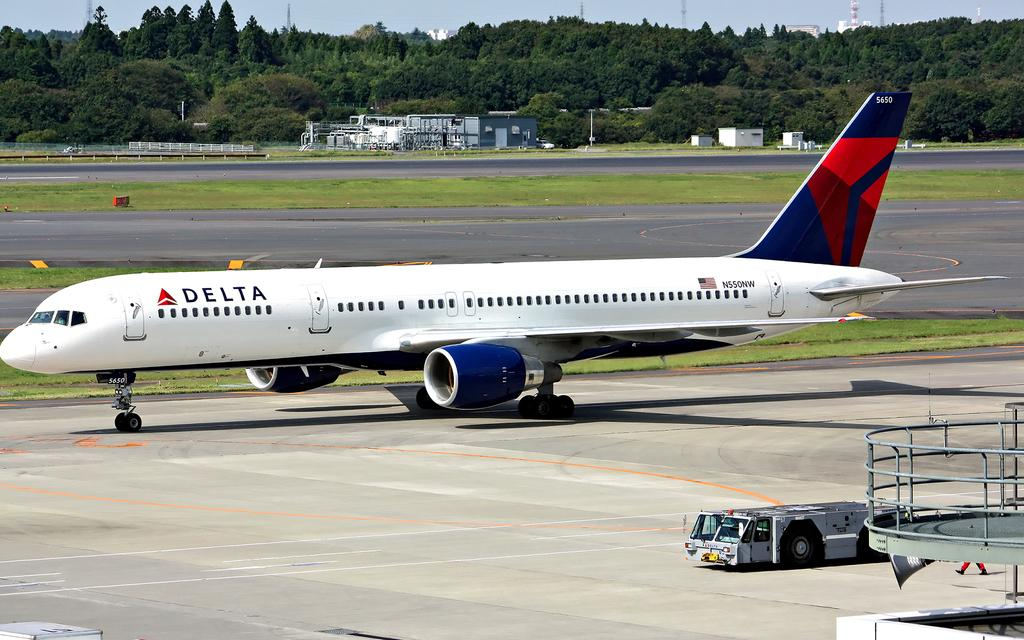<image>
Summarize the visual content of the image. A Delta airline aircraft parked next to an air bus. 